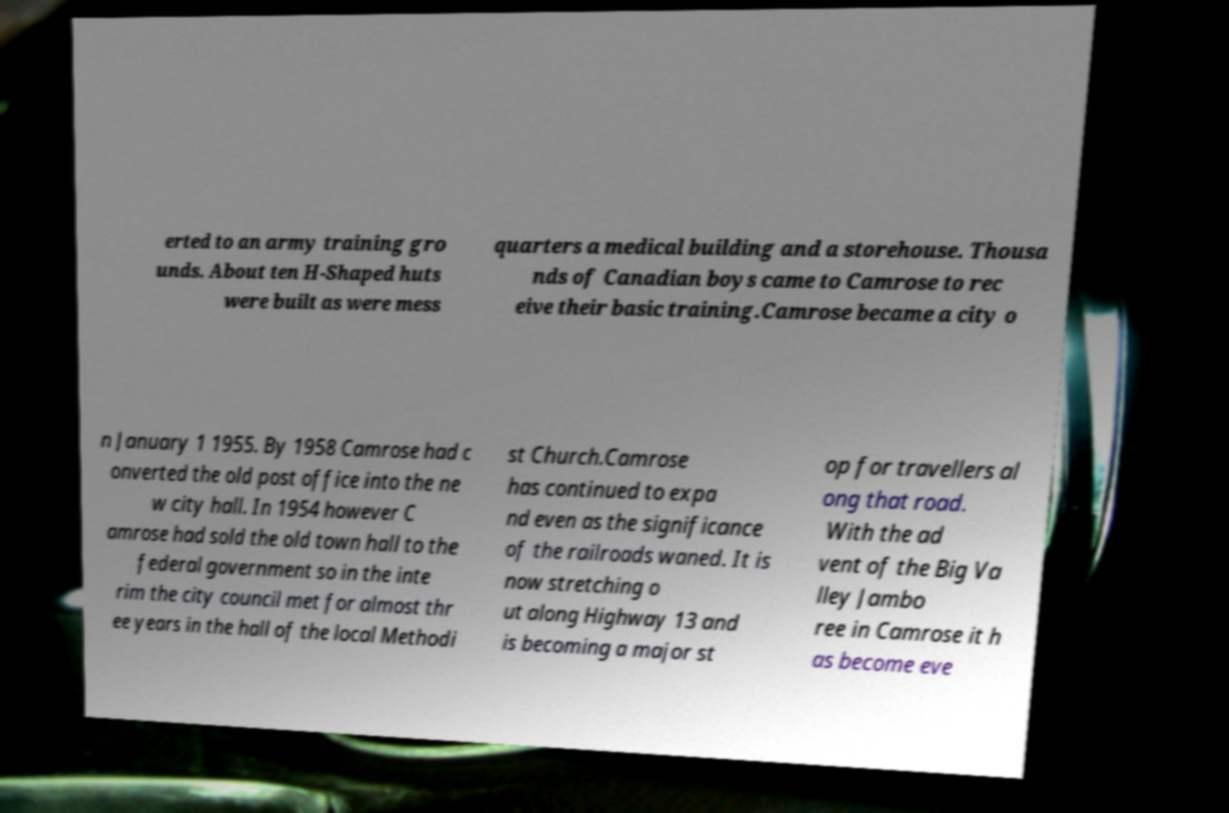Please identify and transcribe the text found in this image. erted to an army training gro unds. About ten H-Shaped huts were built as were mess quarters a medical building and a storehouse. Thousa nds of Canadian boys came to Camrose to rec eive their basic training.Camrose became a city o n January 1 1955. By 1958 Camrose had c onverted the old post office into the ne w city hall. In 1954 however C amrose had sold the old town hall to the federal government so in the inte rim the city council met for almost thr ee years in the hall of the local Methodi st Church.Camrose has continued to expa nd even as the significance of the railroads waned. It is now stretching o ut along Highway 13 and is becoming a major st op for travellers al ong that road. With the ad vent of the Big Va lley Jambo ree in Camrose it h as become eve 